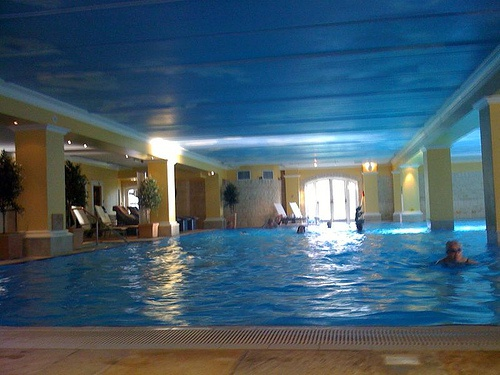Describe the objects in this image and their specific colors. I can see potted plant in black, maroon, and gray tones, potted plant in black, darkgreen, maroon, and gray tones, potted plant in black and gray tones, chair in black and gray tones, and potted plant in black and gray tones in this image. 